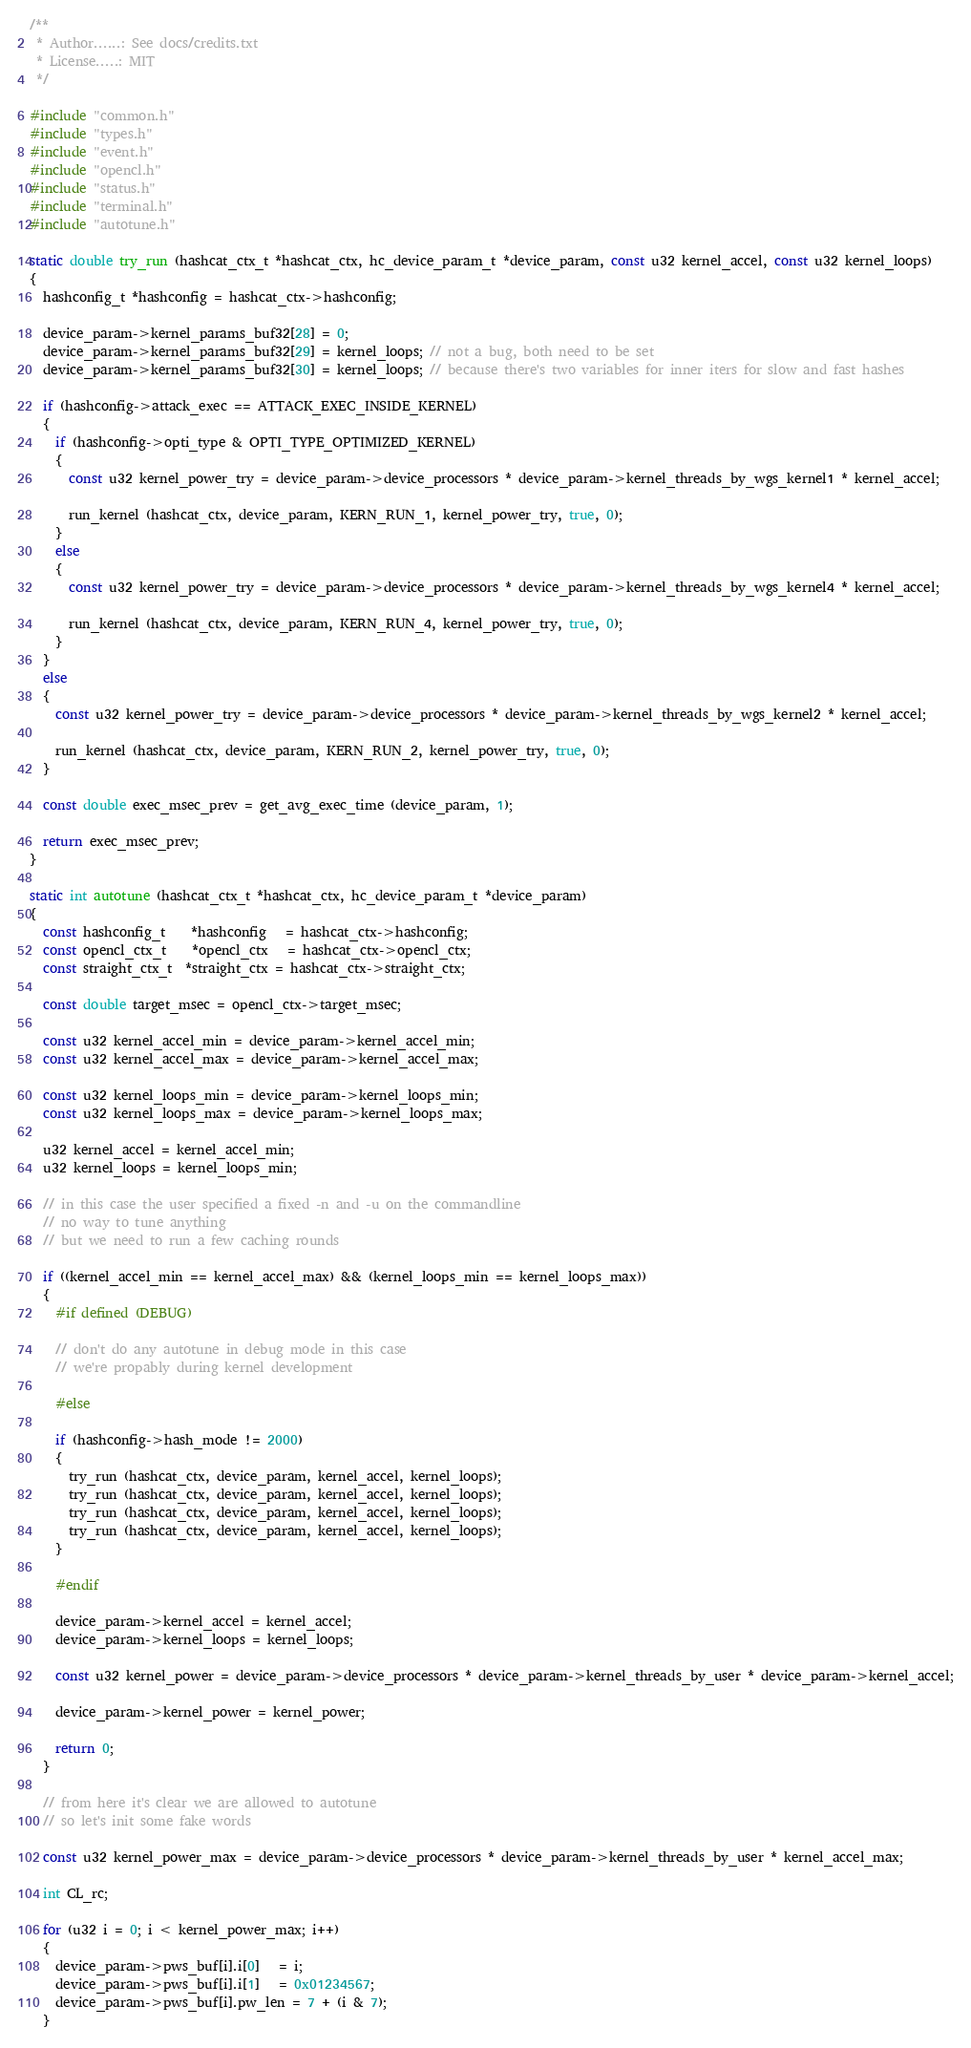Convert code to text. <code><loc_0><loc_0><loc_500><loc_500><_C_>/**
 * Author......: See docs/credits.txt
 * License.....: MIT
 */

#include "common.h"
#include "types.h"
#include "event.h"
#include "opencl.h"
#include "status.h"
#include "terminal.h"
#include "autotune.h"

static double try_run (hashcat_ctx_t *hashcat_ctx, hc_device_param_t *device_param, const u32 kernel_accel, const u32 kernel_loops)
{
  hashconfig_t *hashconfig = hashcat_ctx->hashconfig;

  device_param->kernel_params_buf32[28] = 0;
  device_param->kernel_params_buf32[29] = kernel_loops; // not a bug, both need to be set
  device_param->kernel_params_buf32[30] = kernel_loops; // because there's two variables for inner iters for slow and fast hashes

  if (hashconfig->attack_exec == ATTACK_EXEC_INSIDE_KERNEL)
  {
    if (hashconfig->opti_type & OPTI_TYPE_OPTIMIZED_KERNEL)
    {
      const u32 kernel_power_try = device_param->device_processors * device_param->kernel_threads_by_wgs_kernel1 * kernel_accel;

      run_kernel (hashcat_ctx, device_param, KERN_RUN_1, kernel_power_try, true, 0);
    }
    else
    {
      const u32 kernel_power_try = device_param->device_processors * device_param->kernel_threads_by_wgs_kernel4 * kernel_accel;

      run_kernel (hashcat_ctx, device_param, KERN_RUN_4, kernel_power_try, true, 0);
    }
  }
  else
  {
    const u32 kernel_power_try = device_param->device_processors * device_param->kernel_threads_by_wgs_kernel2 * kernel_accel;

    run_kernel (hashcat_ctx, device_param, KERN_RUN_2, kernel_power_try, true, 0);
  }

  const double exec_msec_prev = get_avg_exec_time (device_param, 1);

  return exec_msec_prev;
}

static int autotune (hashcat_ctx_t *hashcat_ctx, hc_device_param_t *device_param)
{
  const hashconfig_t    *hashconfig   = hashcat_ctx->hashconfig;
  const opencl_ctx_t    *opencl_ctx   = hashcat_ctx->opencl_ctx;
  const straight_ctx_t  *straight_ctx = hashcat_ctx->straight_ctx;

  const double target_msec = opencl_ctx->target_msec;

  const u32 kernel_accel_min = device_param->kernel_accel_min;
  const u32 kernel_accel_max = device_param->kernel_accel_max;

  const u32 kernel_loops_min = device_param->kernel_loops_min;
  const u32 kernel_loops_max = device_param->kernel_loops_max;

  u32 kernel_accel = kernel_accel_min;
  u32 kernel_loops = kernel_loops_min;

  // in this case the user specified a fixed -n and -u on the commandline
  // no way to tune anything
  // but we need to run a few caching rounds

  if ((kernel_accel_min == kernel_accel_max) && (kernel_loops_min == kernel_loops_max))
  {
    #if defined (DEBUG)

    // don't do any autotune in debug mode in this case
    // we're propably during kernel development

    #else

    if (hashconfig->hash_mode != 2000)
    {
      try_run (hashcat_ctx, device_param, kernel_accel, kernel_loops);
      try_run (hashcat_ctx, device_param, kernel_accel, kernel_loops);
      try_run (hashcat_ctx, device_param, kernel_accel, kernel_loops);
      try_run (hashcat_ctx, device_param, kernel_accel, kernel_loops);
    }

    #endif

    device_param->kernel_accel = kernel_accel;
    device_param->kernel_loops = kernel_loops;

    const u32 kernel_power = device_param->device_processors * device_param->kernel_threads_by_user * device_param->kernel_accel;

    device_param->kernel_power = kernel_power;

    return 0;
  }

  // from here it's clear we are allowed to autotune
  // so let's init some fake words

  const u32 kernel_power_max = device_param->device_processors * device_param->kernel_threads_by_user * kernel_accel_max;

  int CL_rc;

  for (u32 i = 0; i < kernel_power_max; i++)
  {
    device_param->pws_buf[i].i[0]   = i;
    device_param->pws_buf[i].i[1]   = 0x01234567;
    device_param->pws_buf[i].pw_len = 7 + (i & 7);
  }
</code> 